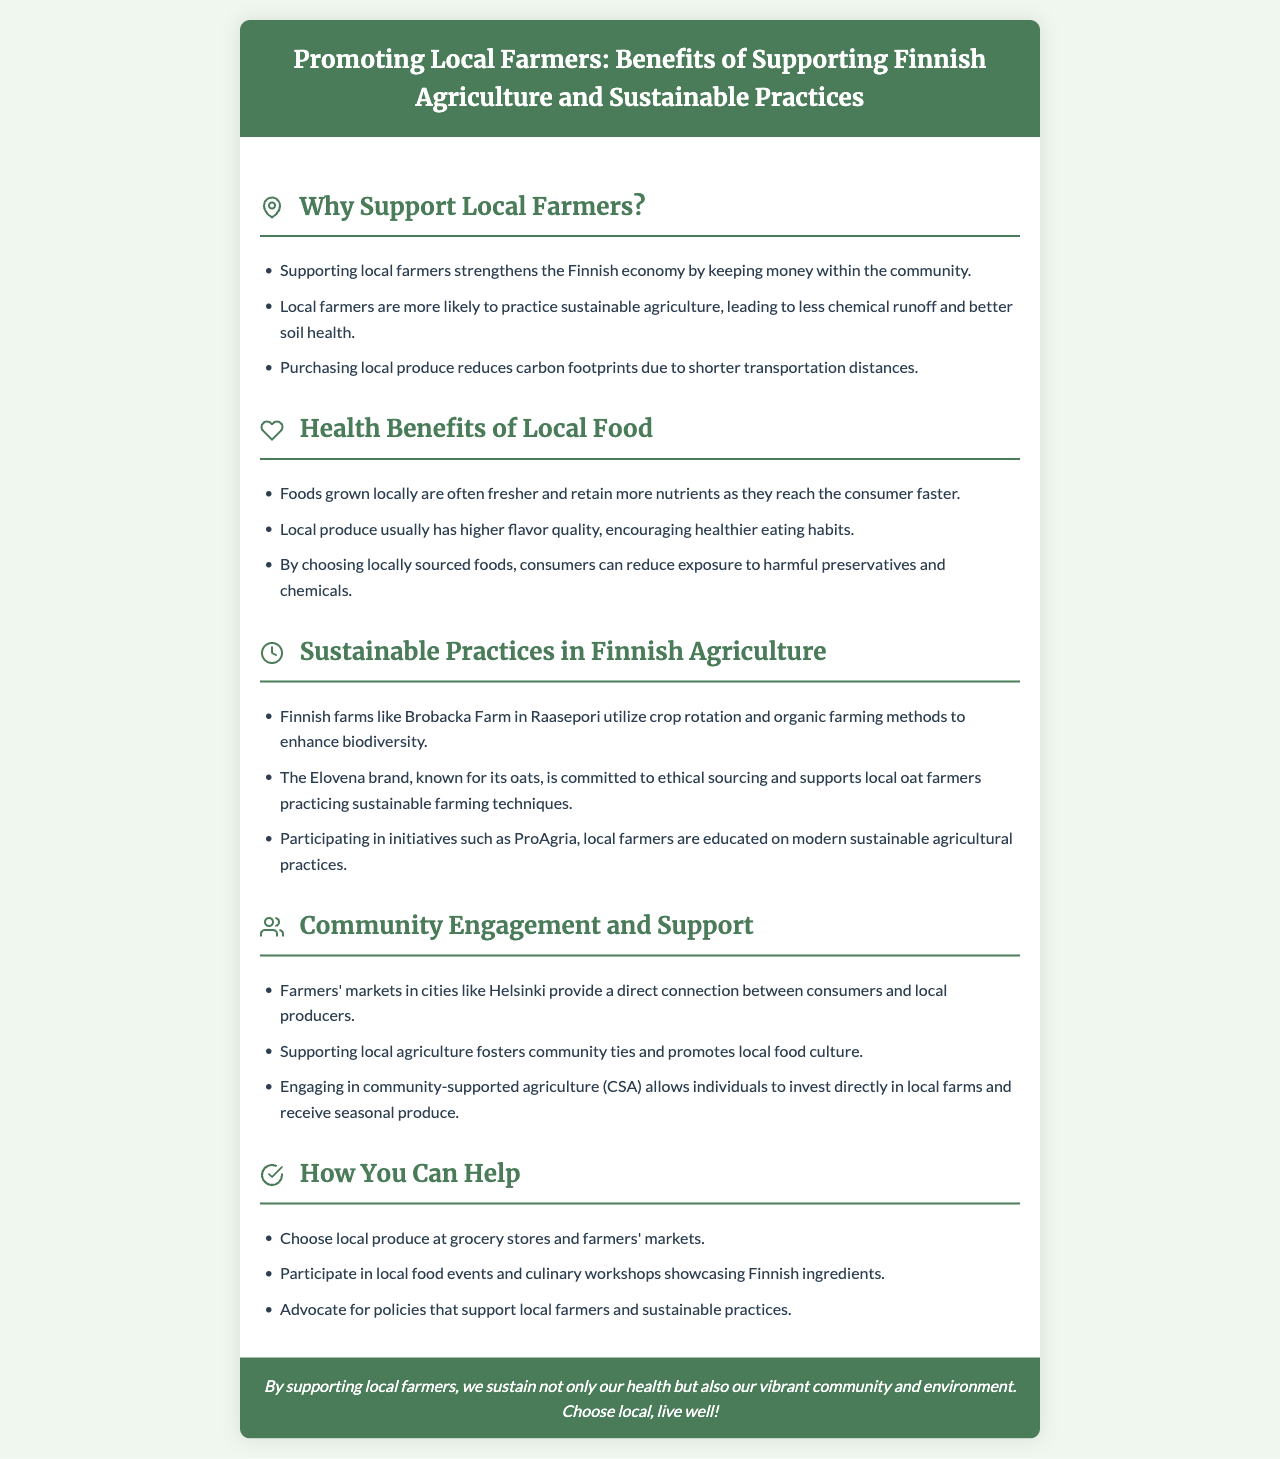Why should you support local farmers? The document lists various reasons for supporting local farmers, including strengthening the economy, sustainable agriculture practices, and reducing carbon footprints.
Answer: Strengthening the Finnish economy What is one health benefit of local food? The brochure states that foods grown locally are often fresher and retain more nutrients as they reach the consumer faster.
Answer: Fresher nutrients Which Finnish farm is mentioned as practicing sustainable agriculture? The document specifically mentions Brobacka Farm in Raasepori as utilizing crop rotation and organic farming methods.
Answer: Brobacka Farm What initiative educates farmers on sustainable practices? The document lists ProAgria as an initiative that helps educate local farmers on modern sustainable agricultural practices.
Answer: ProAgria How can consumers reduce exposure to harmful chemicals? The brochure explains that choosing locally sourced foods helps in reducing exposure to harmful preservatives and chemicals.
Answer: Locally sourced foods What percentage of local farmers practice sustainable farming techniques according to the Elovena brand? The document emphasizes that the Elovena brand supports local oat farmers practicing sustainable farming techniques, but does not specify a percentage.
Answer: Not specified What community engagement activity is mentioned? The brochure describes farmers' markets as providing a direct connection between consumers and local producers.
Answer: Farmers' markets What is one way consumers can help local farmers? The document suggests that consumers choose local produce at grocery stores and farmers' markets to support local farmers.
Answer: Choose local produce 